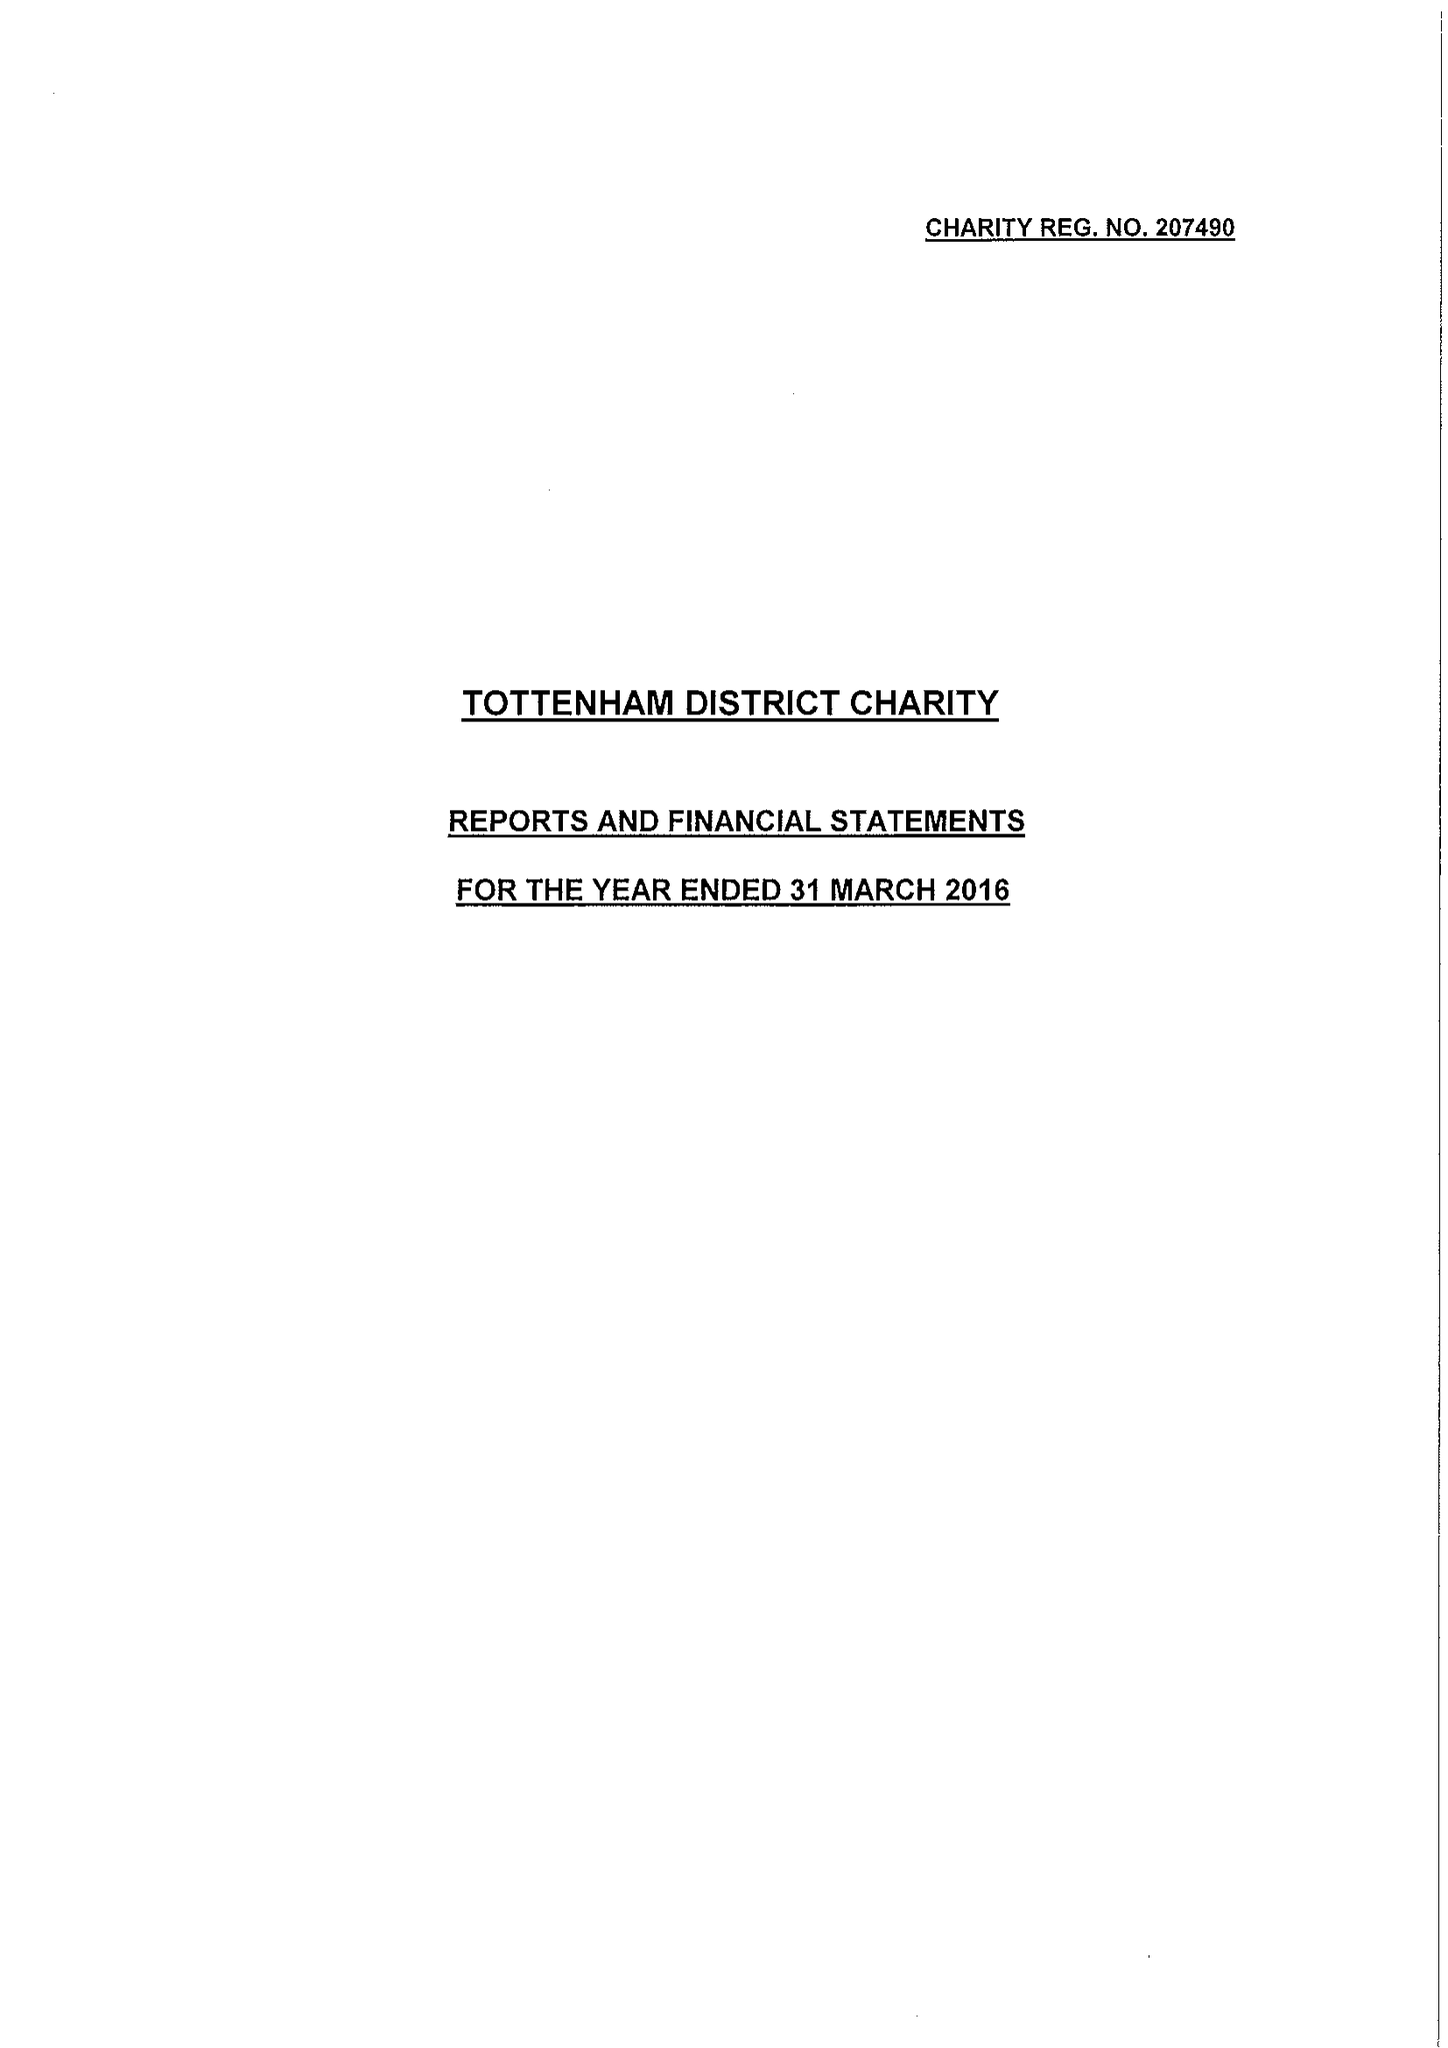What is the value for the spending_annually_in_british_pounds?
Answer the question using a single word or phrase. 103938.00 